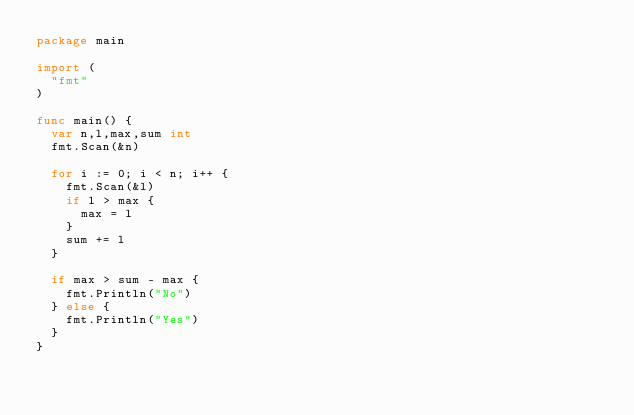<code> <loc_0><loc_0><loc_500><loc_500><_Go_>package main

import (
	"fmt"
)

func main() {
	var n,l,max,sum int
	fmt.Scan(&n)
	
	for i := 0; i < n; i++ {
		fmt.Scan(&l)
		if l > max {
			max = l
		}
		sum += l
	}
	
	if max > sum - max {
		fmt.Println("No")
	} else {
		fmt.Println("Yes")
	}
}</code> 